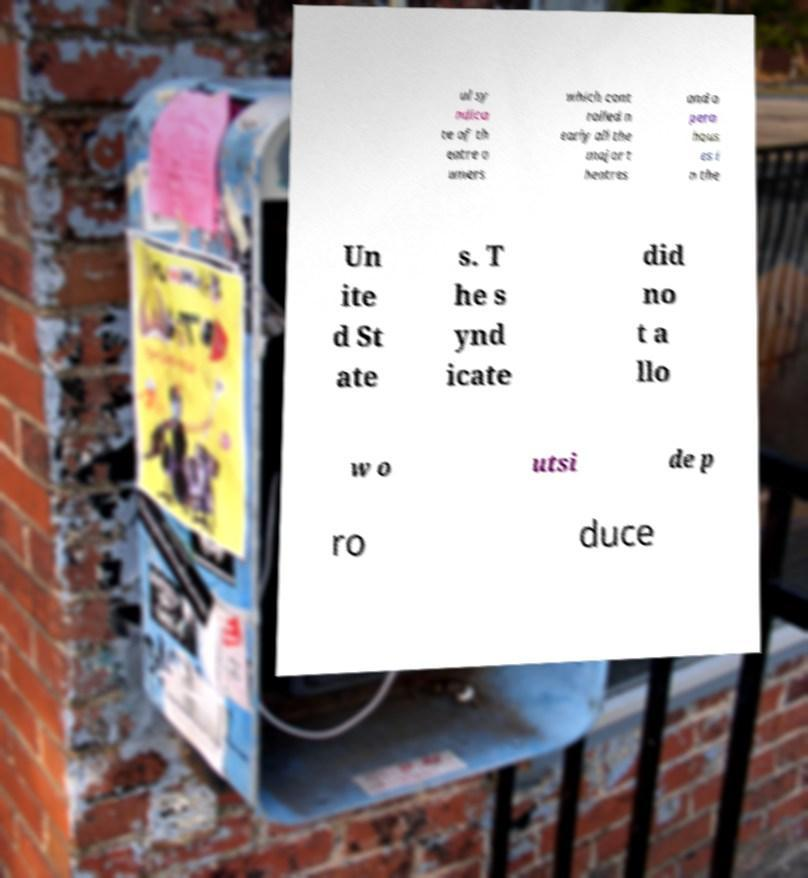I need the written content from this picture converted into text. Can you do that? ul sy ndica te of th eatre o wners which cont rolled n early all the major t heatres and o pera hous es i n the Un ite d St ate s. T he s ynd icate did no t a llo w o utsi de p ro duce 